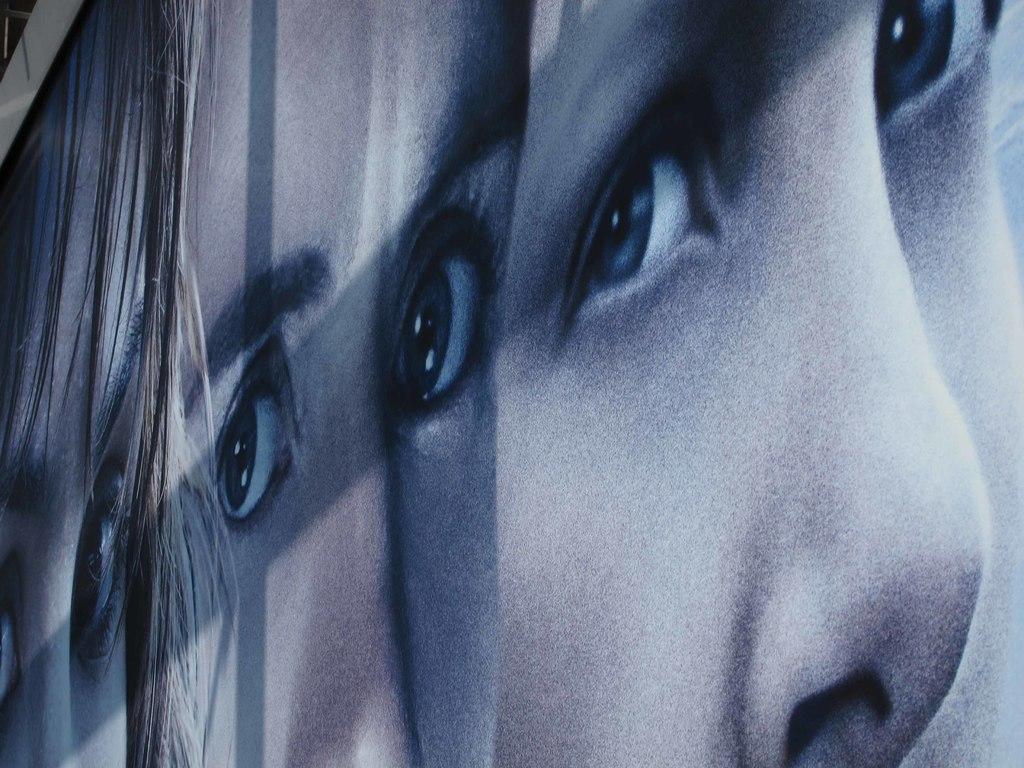Describe this image in one or two sentences. This picture shows a collage of the same picture. We see a girl. 